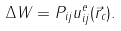<formula> <loc_0><loc_0><loc_500><loc_500>\Delta W = P _ { i j } u ^ { e } _ { i j } ( { \vec { r } _ { c } } ) .</formula> 